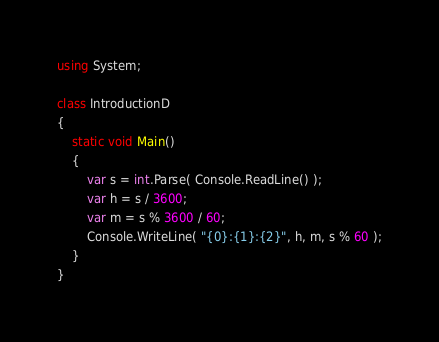Convert code to text. <code><loc_0><loc_0><loc_500><loc_500><_C#_>using System;
 
class IntroductionD
{
    static void Main()
    {
        var s = int.Parse( Console.ReadLine() );
        var h = s / 3600;
        var m = s % 3600 / 60;
        Console.WriteLine( "{0}:{1}:{2}", h, m, s % 60 );
    }
}</code> 